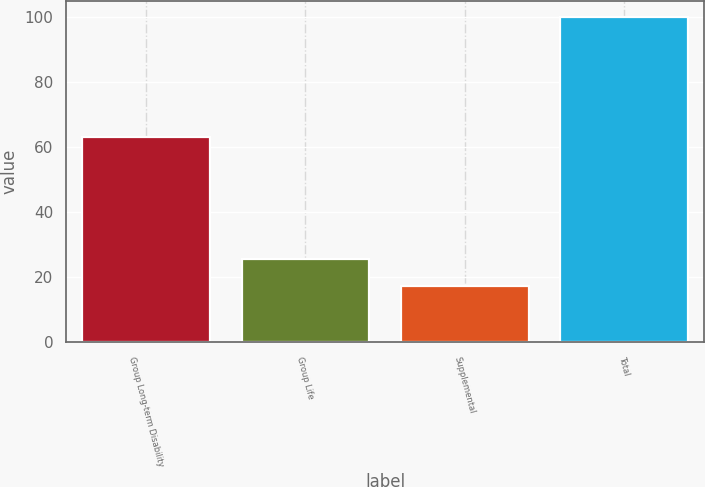Convert chart to OTSL. <chart><loc_0><loc_0><loc_500><loc_500><bar_chart><fcel>Group Long-term Disability<fcel>Group Life<fcel>Supplemental<fcel>Total<nl><fcel>63.1<fcel>25.66<fcel>17.4<fcel>100<nl></chart> 